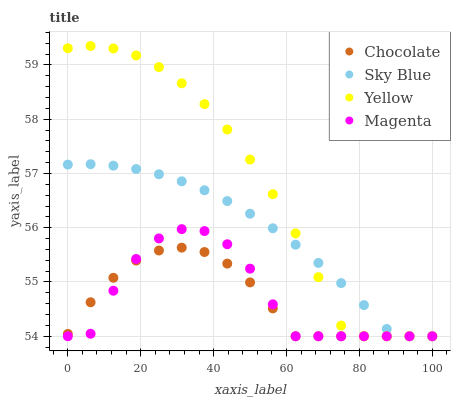Does Chocolate have the minimum area under the curve?
Answer yes or no. Yes. Does Yellow have the maximum area under the curve?
Answer yes or no. Yes. Does Magenta have the minimum area under the curve?
Answer yes or no. No. Does Magenta have the maximum area under the curve?
Answer yes or no. No. Is Sky Blue the smoothest?
Answer yes or no. Yes. Is Magenta the roughest?
Answer yes or no. Yes. Is Yellow the smoothest?
Answer yes or no. No. Is Yellow the roughest?
Answer yes or no. No. Does Sky Blue have the lowest value?
Answer yes or no. Yes. Does Yellow have the highest value?
Answer yes or no. Yes. Does Magenta have the highest value?
Answer yes or no. No. Does Sky Blue intersect Magenta?
Answer yes or no. Yes. Is Sky Blue less than Magenta?
Answer yes or no. No. Is Sky Blue greater than Magenta?
Answer yes or no. No. 